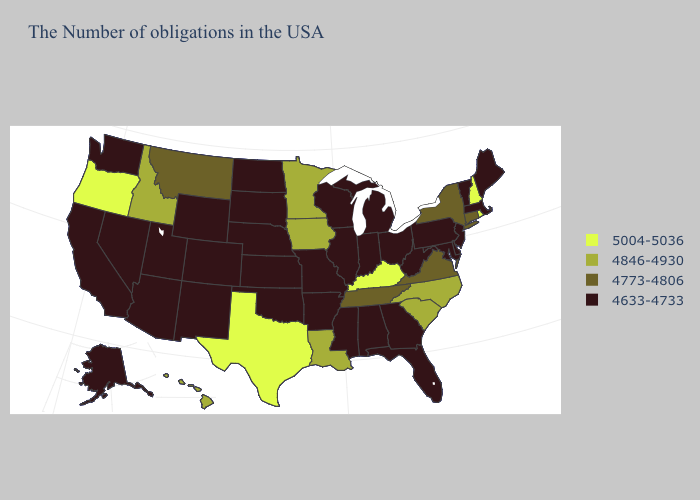Among the states that border Delaware , which have the highest value?
Answer briefly. New Jersey, Maryland, Pennsylvania. Does the map have missing data?
Write a very short answer. No. Does North Carolina have the same value as Tennessee?
Give a very brief answer. No. Among the states that border Montana , does South Dakota have the highest value?
Short answer required. No. What is the value of Nevada?
Write a very short answer. 4633-4733. What is the value of New York?
Keep it brief. 4773-4806. Does Hawaii have the lowest value in the West?
Write a very short answer. No. Does New York have a lower value than Montana?
Short answer required. No. Does West Virginia have the highest value in the South?
Short answer required. No. Among the states that border Texas , does Oklahoma have the highest value?
Be succinct. No. Which states have the lowest value in the USA?
Short answer required. Maine, Massachusetts, Vermont, New Jersey, Delaware, Maryland, Pennsylvania, West Virginia, Ohio, Florida, Georgia, Michigan, Indiana, Alabama, Wisconsin, Illinois, Mississippi, Missouri, Arkansas, Kansas, Nebraska, Oklahoma, South Dakota, North Dakota, Wyoming, Colorado, New Mexico, Utah, Arizona, Nevada, California, Washington, Alaska. Among the states that border Washington , which have the lowest value?
Keep it brief. Idaho. Among the states that border New Jersey , does Pennsylvania have the lowest value?
Quick response, please. Yes. 